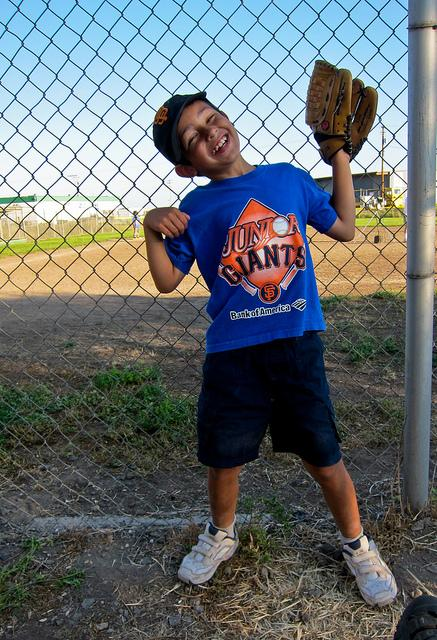What is on the boy's hand? Please explain your reasoning. glove. The boy is playing baseball. he is wearing an item that allows him to catch a ball. 